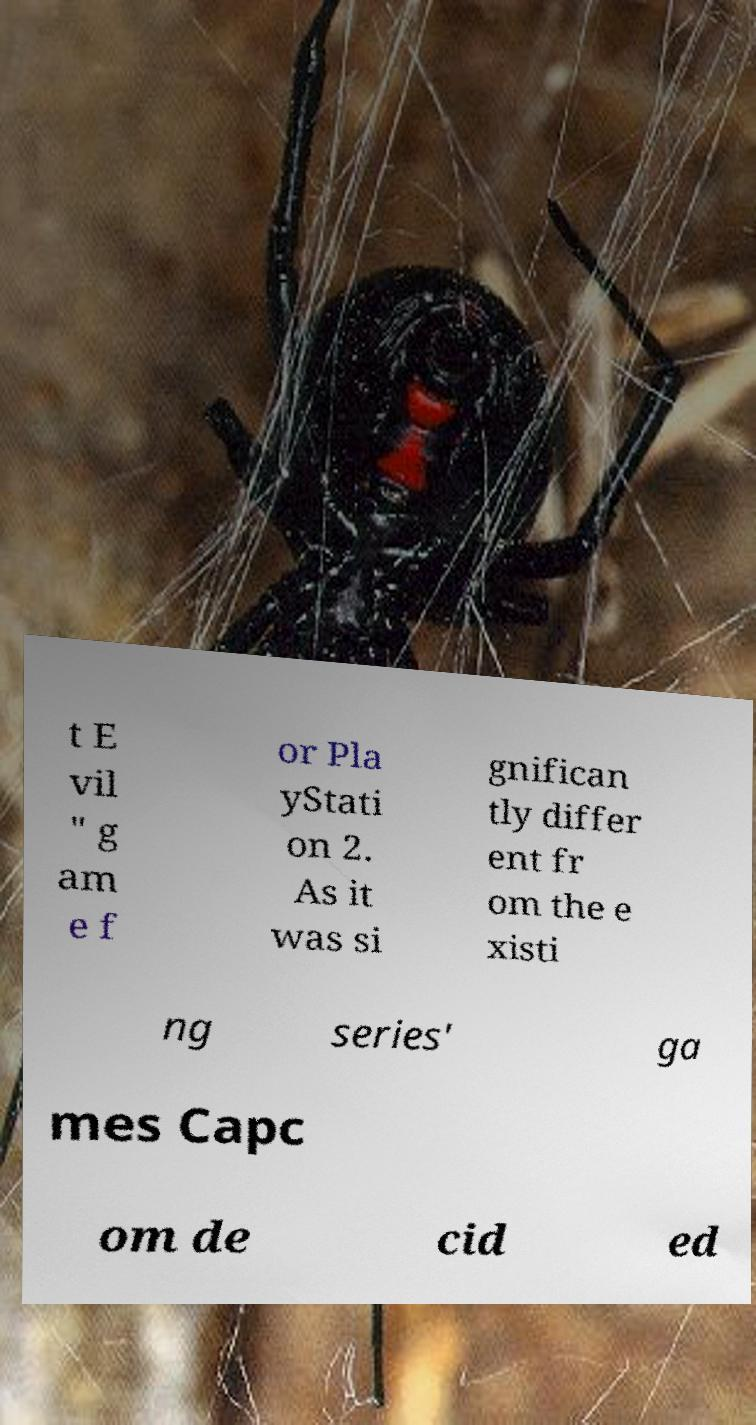There's text embedded in this image that I need extracted. Can you transcribe it verbatim? t E vil " g am e f or Pla yStati on 2. As it was si gnifican tly differ ent fr om the e xisti ng series' ga mes Capc om de cid ed 